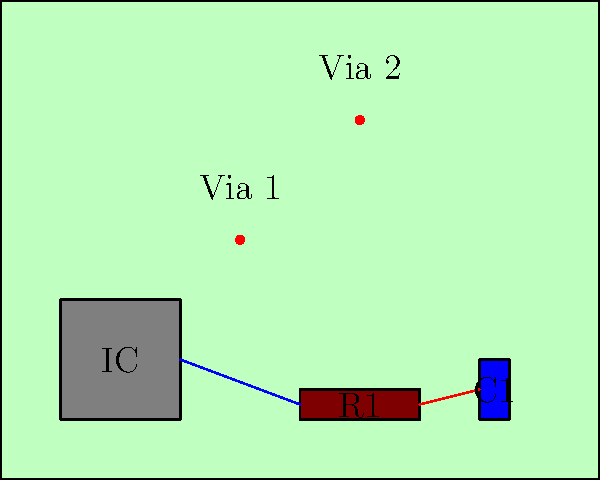As the executive overseeing our company's electronics division, you're reviewing a new PCB design. Identify the component that connects directly to both R1 and C1, and explain its potential role in signal processing or power management. To answer this question, let's analyze the PCB layout step-by-step:

1. Observe the components on the PCB:
   - IC: A large square component labeled "IC"
   - R1: A rectangular component labeled "R1" (likely a resistor)
   - C1: A small rectangular component labeled "C1" (likely a capacitor)

2. Examine the connections:
   - There's a blue line connecting the IC to R1
   - There's a red line connecting R1 to C1

3. Identify the component connected to both R1 and C1:
   - R1 is directly connected to both the IC and C1
   - Therefore, R1 is the component that connects to both R1 and C1

4. Consider the potential role of R1:
   - In signal processing: R1 could be part of a low-pass or high-pass filter when combined with C1
   - In power management: R1 could be a current-limiting resistor or part of a voltage divider

5. Conclusion:
   The resistor R1 is the component that connects directly to both the IC and C1. Its role could be crucial in either signal processing or power management, depending on the specific circuit design and requirements.
Answer: R1 (resistor) 